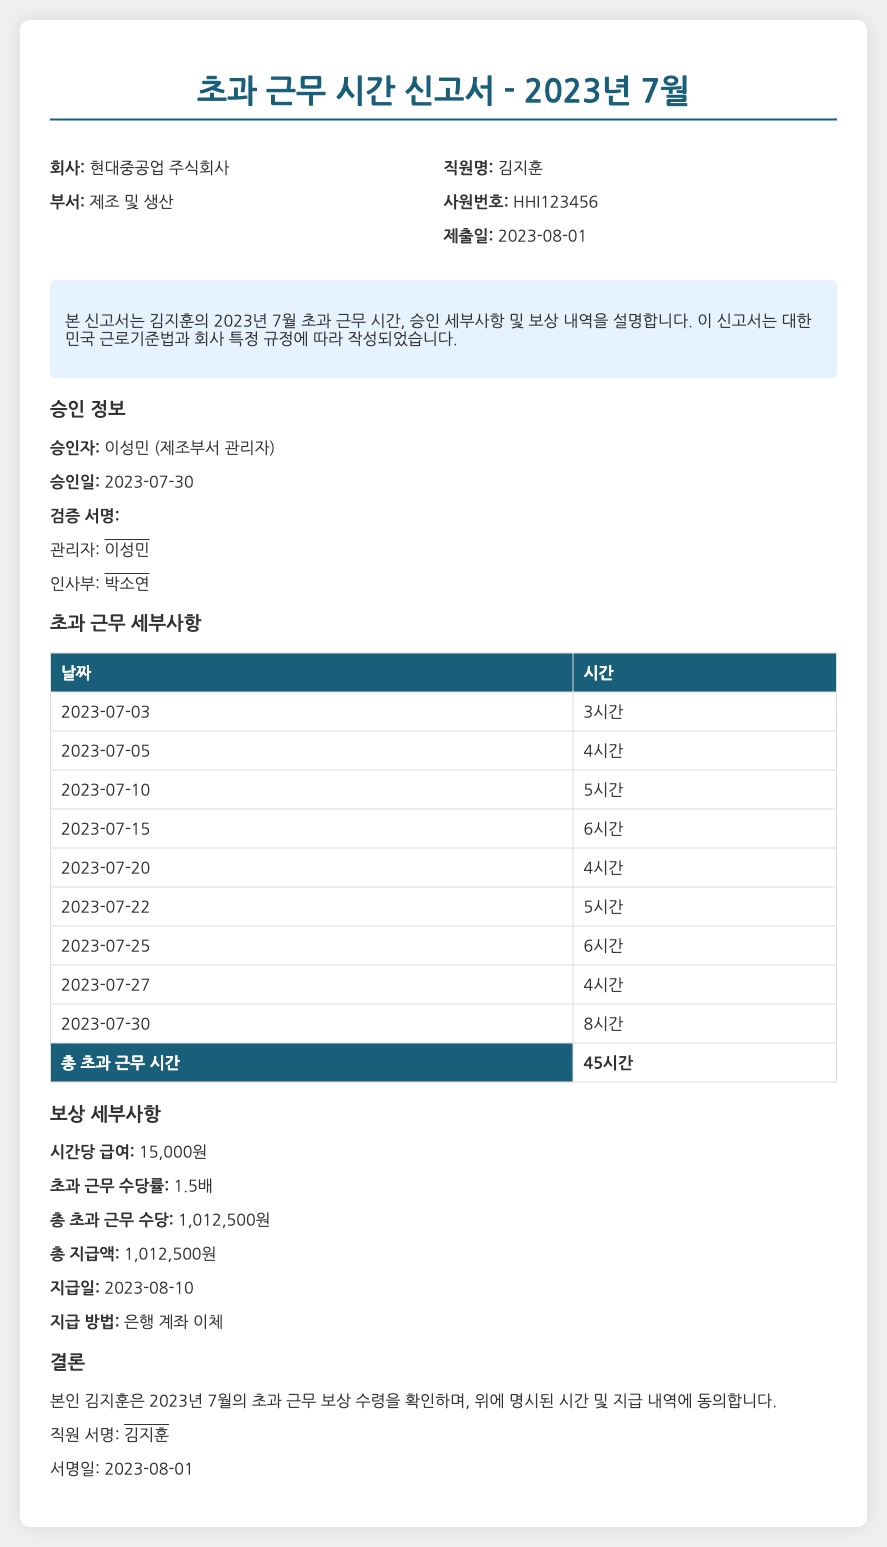직원명은 무엇인가요? 직원명은 신고서에서 직원을 식별하는 정보로, 김지훈이란 이름이 기재되어 있습니다.
Answer: 김지훈 총 초과 근무 시간은 얼마인가요? 총 초과 근무 시간은 신고서에 명시된 모든 초과 근무 시간을 합산한 결과로, 45시간이 기재되어 있습니다.
Answer: 45시간 승인자는 누구인가요? 승인자는 초과 근무 신고서를 허가한 관리자 정보로, 이성민의 이름이 기록되어 있습니다.
Answer: 이성민 초과 근무 수당률은 얼마인가요? 초과 근무 수당률은 초과 근무에 대한 보상의 비율로, 1.5배로 설정되어 있습니다.
Answer: 1.5배 지급일자는 언제인가요? 지급일자는 회사에서 초과 근무 수당을 지급하는 날짜로, 2023-08-10으로 명시되어 있습니다.
Answer: 2023-08-10 총 지급액은 얼마인가요? 총 지급액은 초과 근무로 인해 지급될 금액으로, 신고서에 1,012,500원이 기재되어 있습니다.
Answer: 1,012,500원 이 문서의 종류는 무엇인가요? 이 문서는 근로자의 초과 근무를 신고하고 보상을 요청하는 공식적인 문서입니다.
Answer: 초과 근무 시간 신고서 검증 서명자는 누구인가요? 검증 서명자는 인사부에서 서명할 책임이 있는 사람으로, 박소연의 이름이 기재되어 있습니다.
Answer: 박소연 초과 근무를 한 날짜 중 가장 빠른 날짜는 언제인가요? 초과 근무를 한 날짜 중 가장 빠른 날짜는 신고서에 처음 기재된 날짜로, 2023-07-03입니다.
Answer: 2023-07-03 